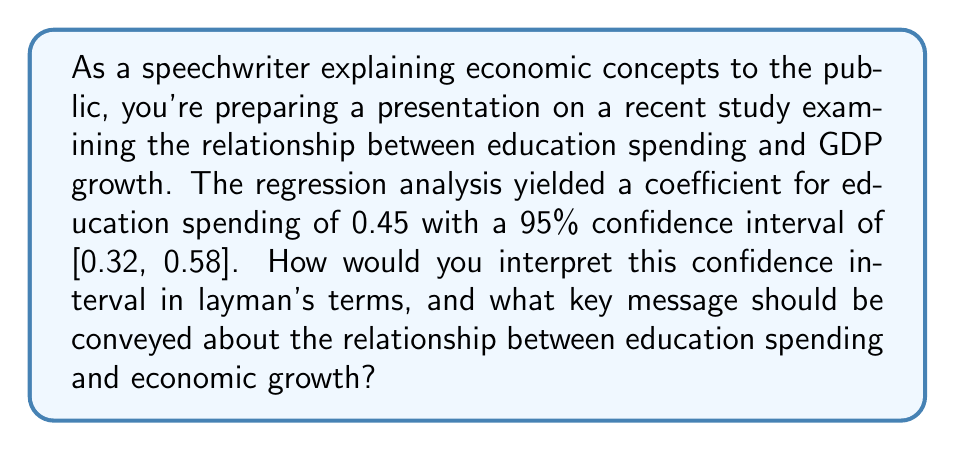Give your solution to this math problem. To interpret the confidence interval for a regression coefficient, we need to follow these steps:

1. Understand the coefficient:
   The coefficient 0.45 suggests that for every 1 unit increase in education spending, there's an associated 0.45 unit increase in GDP growth.

2. Interpret the confidence interval:
   The 95% confidence interval [0.32, 0.58] means we can be 95% confident that the true population parameter (the actual effect of education spending on GDP growth) lies between 0.32 and 0.58.

3. Check for statistical significance:
   Since the confidence interval doesn't include 0, we can conclude that the relationship between education spending and GDP growth is statistically significant at the 5% level.

4. Interpret the range:
   - Lower bound (0.32): At minimum, we expect a 0.32 unit increase in GDP growth for every 1 unit increase in education spending.
   - Upper bound (0.58): At maximum, we expect a 0.58 unit increase in GDP growth for every 1 unit increase in education spending.

5. Key message for the public:
   The study provides strong evidence of a positive relationship between education spending and economic growth. We can be quite confident that increased investment in education is associated with higher GDP growth, with the effect likely falling between 0.32 and 0.58 units of growth per unit of spending.
Answer: There's a 95% chance that each unit increase in education spending is associated with a 0.32 to 0.58 unit increase in GDP growth, indicating a significant positive relationship between education investment and economic growth. 